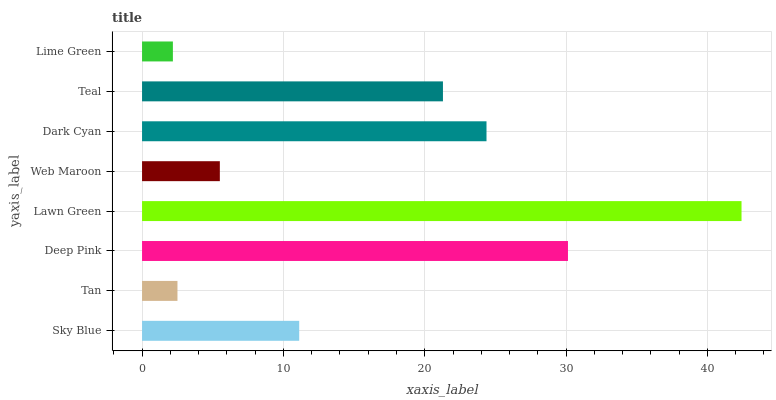Is Lime Green the minimum?
Answer yes or no. Yes. Is Lawn Green the maximum?
Answer yes or no. Yes. Is Tan the minimum?
Answer yes or no. No. Is Tan the maximum?
Answer yes or no. No. Is Sky Blue greater than Tan?
Answer yes or no. Yes. Is Tan less than Sky Blue?
Answer yes or no. Yes. Is Tan greater than Sky Blue?
Answer yes or no. No. Is Sky Blue less than Tan?
Answer yes or no. No. Is Teal the high median?
Answer yes or no. Yes. Is Sky Blue the low median?
Answer yes or no. Yes. Is Deep Pink the high median?
Answer yes or no. No. Is Web Maroon the low median?
Answer yes or no. No. 